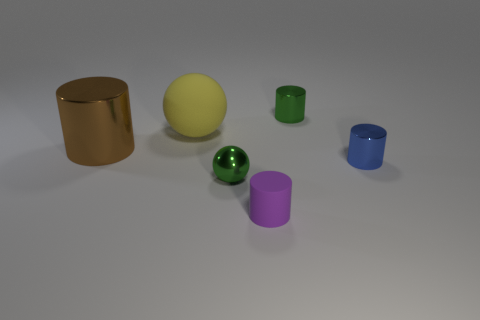There is a tiny green metal object behind the big metallic cylinder; does it have the same shape as the large brown metal thing?
Make the answer very short. Yes. What material is the small cylinder that is the same color as the tiny sphere?
Your answer should be compact. Metal. What number of small rubber things have the same color as the big metal cylinder?
Keep it short and to the point. 0. The matte thing behind the tiny green thing that is in front of the small blue object is what shape?
Your response must be concise. Sphere. Are there any small blue rubber things that have the same shape as the yellow object?
Offer a terse response. No. Is the color of the small matte cylinder the same as the rubber ball behind the rubber cylinder?
Your answer should be compact. No. What size is the thing that is the same color as the small sphere?
Provide a succinct answer. Small. Are there any brown metal cylinders that have the same size as the blue cylinder?
Ensure brevity in your answer.  No. Do the tiny blue cylinder and the green object behind the tiny blue thing have the same material?
Your response must be concise. Yes. Are there more large yellow matte balls than small red cylinders?
Your answer should be very brief. Yes. 